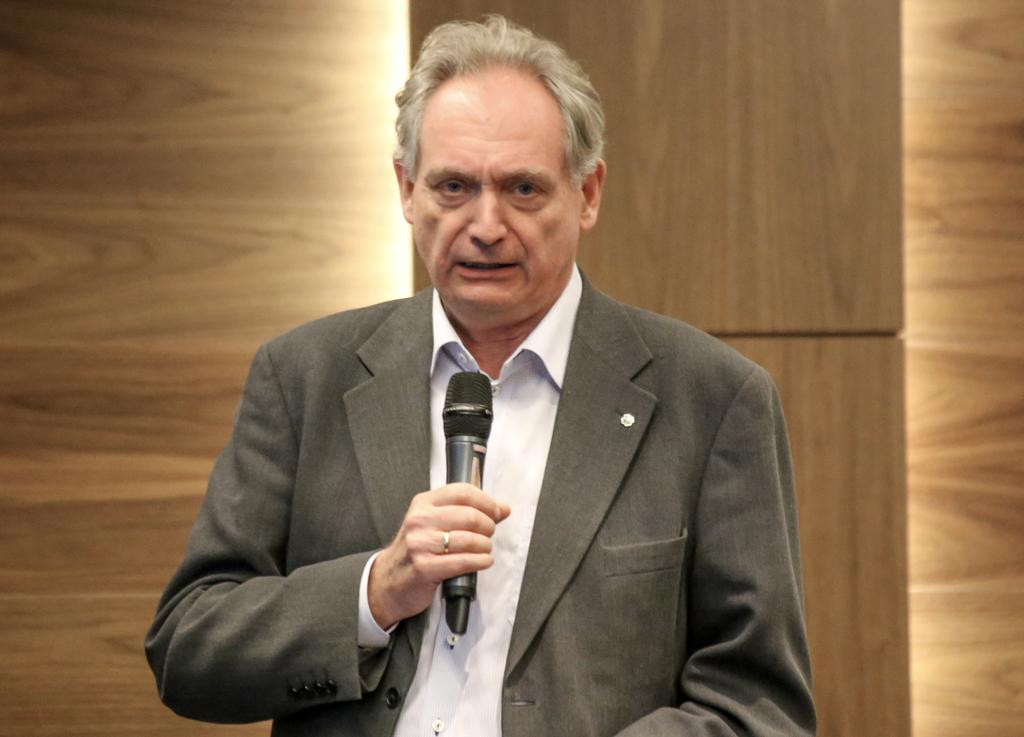Who is present in the image? There is a man in the image. What is the man wearing? The man is wearing a blazer. What object is the man holding? The man is holding a microphone. What can be seen in the background of the image? There is a wooden wall in the background of the image. Where is the straw located in the image? There is no straw present in the image. Can you see a stream in the background of the image? There is no stream visible in the image; it features a wooden wall in the background. 